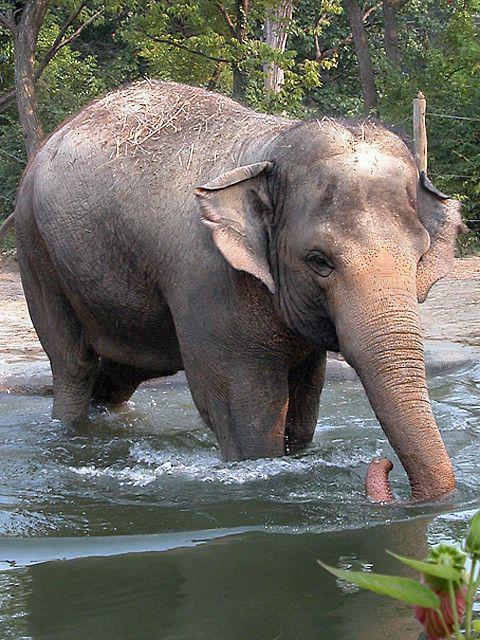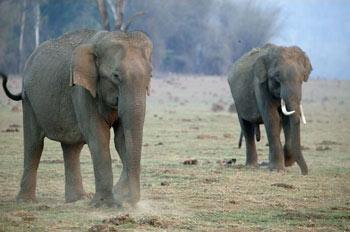The first image is the image on the left, the second image is the image on the right. Evaluate the accuracy of this statement regarding the images: "There are more animals on the left than the right.". Is it true? Answer yes or no. No. 